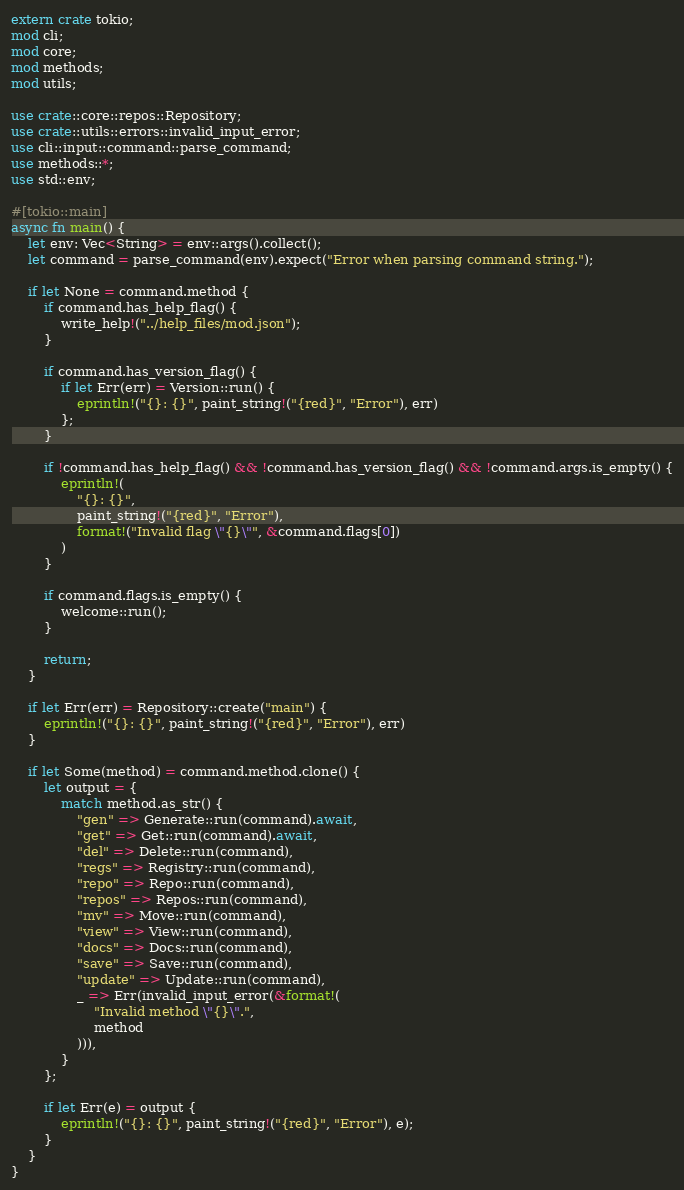<code> <loc_0><loc_0><loc_500><loc_500><_Rust_>extern crate tokio;
mod cli;
mod core;
mod methods;
mod utils;

use crate::core::repos::Repository;
use crate::utils::errors::invalid_input_error;
use cli::input::command::parse_command;
use methods::*;
use std::env;

#[tokio::main]
async fn main() {
    let env: Vec<String> = env::args().collect();
    let command = parse_command(env).expect("Error when parsing command string.");

    if let None = command.method {
        if command.has_help_flag() {
            write_help!("../help_files/mod.json");
        }

        if command.has_version_flag() {
            if let Err(err) = Version::run() {
                eprintln!("{}: {}", paint_string!("{red}", "Error"), err)
            };
        }

        if !command.has_help_flag() && !command.has_version_flag() && !command.args.is_empty() {
            eprintln!(
                "{}: {}",
                paint_string!("{red}", "Error"),
                format!("Invalid flag \"{}\"", &command.flags[0])
            )
        }

        if command.flags.is_empty() {
            welcome::run();
        }

        return;
    }

    if let Err(err) = Repository::create("main") {
        eprintln!("{}: {}", paint_string!("{red}", "Error"), err)
    }

    if let Some(method) = command.method.clone() {
        let output = {
            match method.as_str() {
                "gen" => Generate::run(command).await,
                "get" => Get::run(command).await,
                "del" => Delete::run(command),
                "regs" => Registry::run(command),
                "repo" => Repo::run(command),
                "repos" => Repos::run(command),
                "mv" => Move::run(command),
                "view" => View::run(command),
                "docs" => Docs::run(command),
                "save" => Save::run(command),
                "update" => Update::run(command),
                _ => Err(invalid_input_error(&format!(
                    "Invalid method \"{}\".",
                    method
                ))),
            }
        };

        if let Err(e) = output {
            eprintln!("{}: {}", paint_string!("{red}", "Error"), e);
        }
    }
}
</code> 